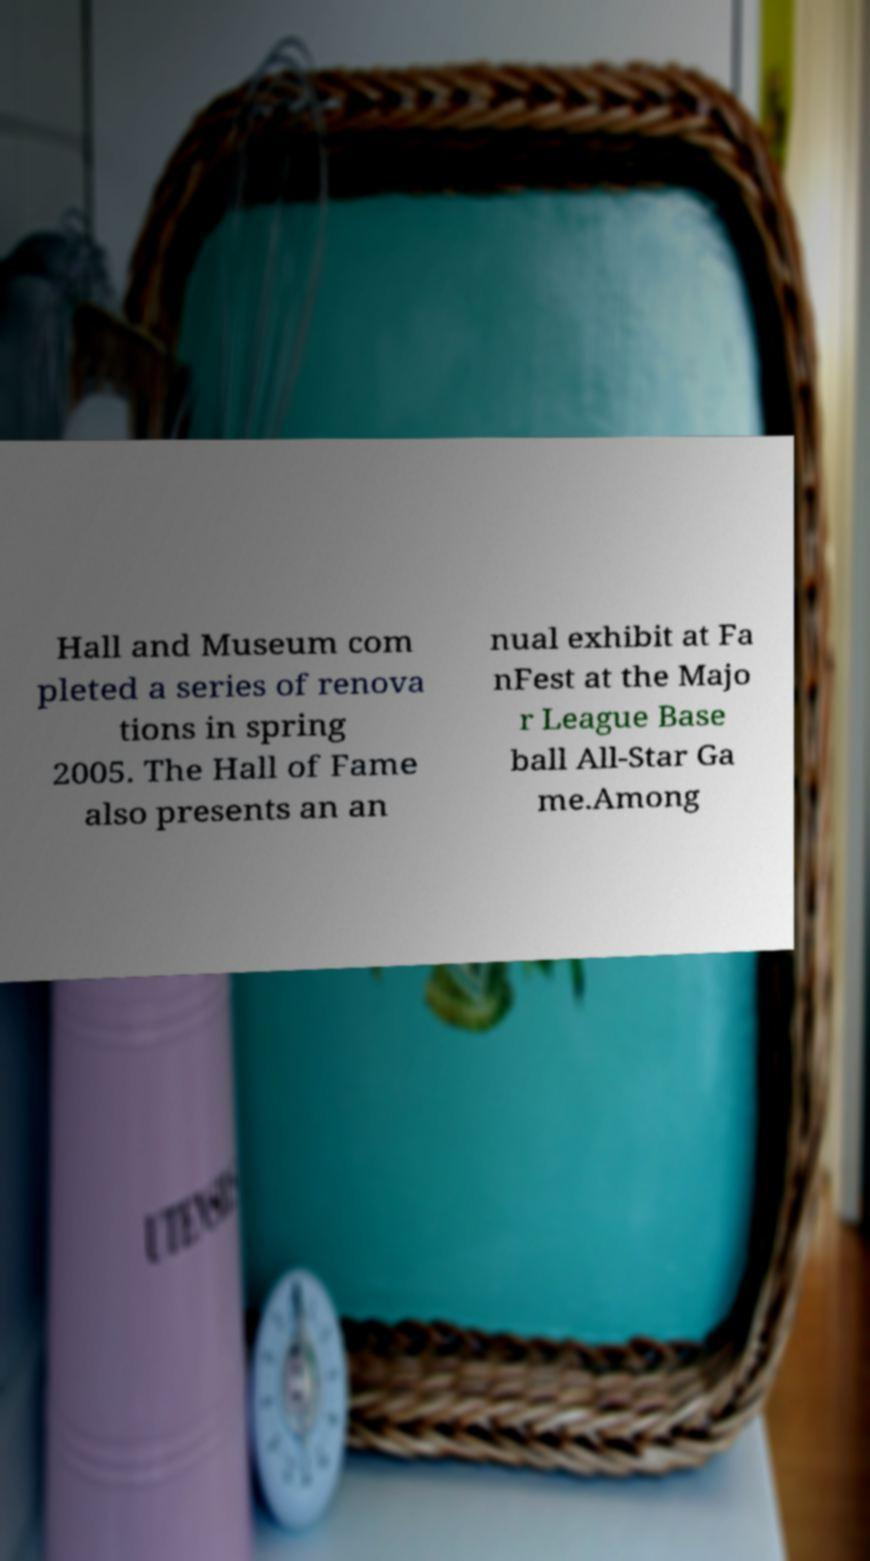What messages or text are displayed in this image? I need them in a readable, typed format. Hall and Museum com pleted a series of renova tions in spring 2005. The Hall of Fame also presents an an nual exhibit at Fa nFest at the Majo r League Base ball All-Star Ga me.Among 